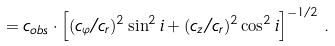<formula> <loc_0><loc_0><loc_500><loc_500>\label 2 c _ { r } = c _ { o b s } \cdot \left [ ( c _ { \varphi } / c _ { r } ) ^ { 2 } \sin ^ { 2 } i + ( c _ { z } / c _ { r } ) ^ { 2 } \cos ^ { 2 } i \right ] ^ { - 1 / 2 } \, .</formula> 